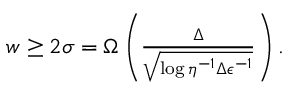Convert formula to latex. <formula><loc_0><loc_0><loc_500><loc_500>\begin{array} { r } { w \geq 2 \sigma = \Omega \left ( \frac { \Delta } { \sqrt { \log { \eta ^ { - 1 } \Delta \epsilon ^ { - 1 } } } } \right ) . } \end{array}</formula> 